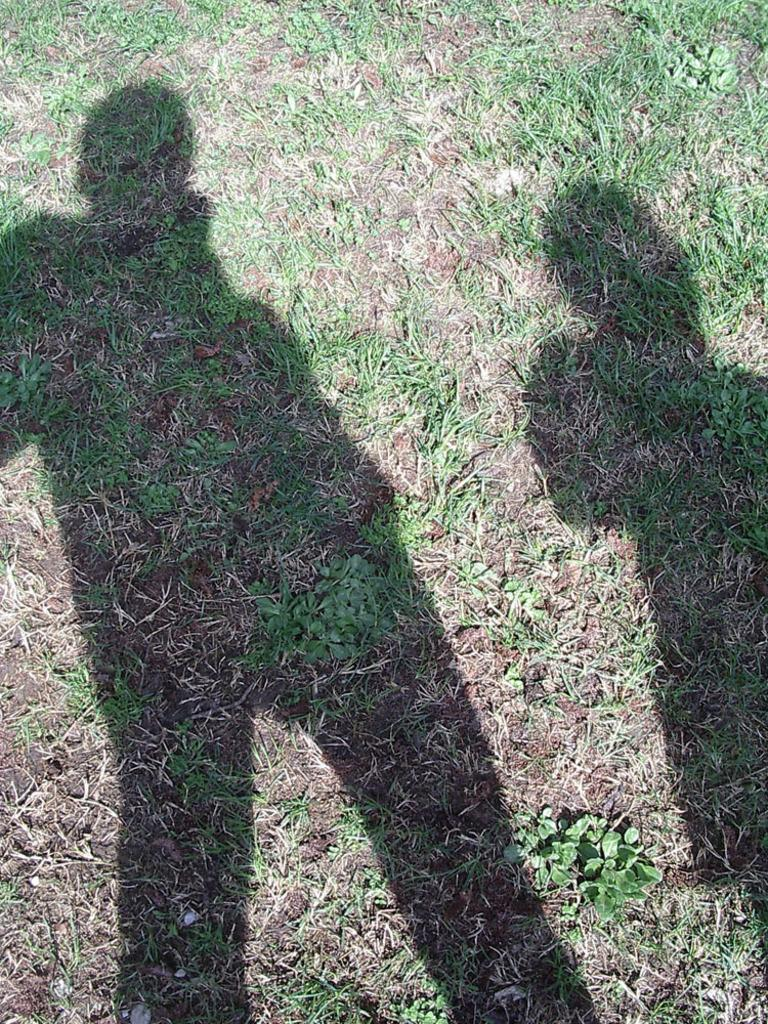What type of surface is visible on the ground in the image? The ground in the image is covered with grass. Can you describe any additional features on the ground? Yes, there are shadows of persons on the ground. What type of book is being read by the person in the image? There is no person or book visible in the image; it only shows shadows of persons on the ground. 